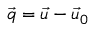<formula> <loc_0><loc_0><loc_500><loc_500>\vec { q } = \vec { u } - \vec { u } _ { 0 }</formula> 